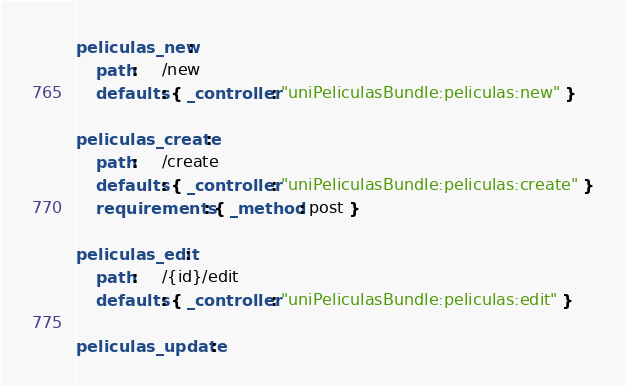<code> <loc_0><loc_0><loc_500><loc_500><_YAML_>
peliculas_new:
    path:     /new
    defaults: { _controller: "uniPeliculasBundle:peliculas:new" }

peliculas_create:
    path:     /create
    defaults: { _controller: "uniPeliculasBundle:peliculas:create" }
    requirements: { _method: post }

peliculas_edit:
    path:     /{id}/edit
    defaults: { _controller: "uniPeliculasBundle:peliculas:edit" }

peliculas_update:</code> 